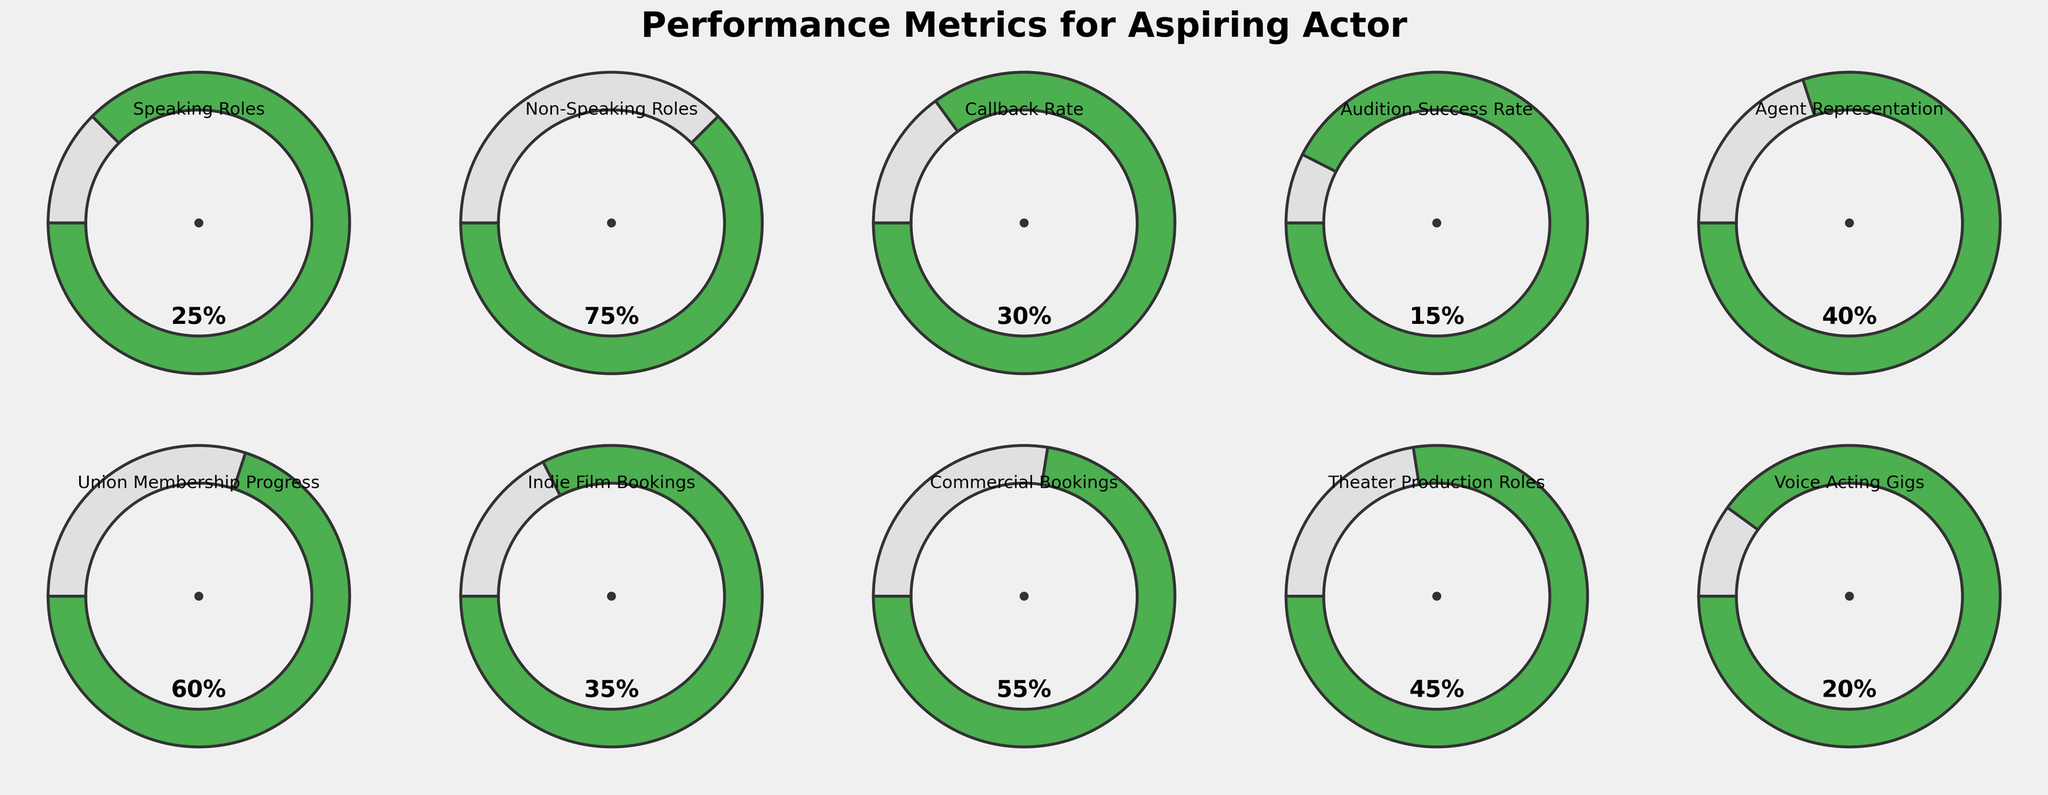What is the title of the figure? The title of the figure is displayed at the top and reads "Performance Metrics for Aspiring Actor." The title helps to understand what information the figure aims to convey.
Answer: Performance Metrics for Aspiring Actor What is the value for 'Voice Acting Gigs'? The value can be found inside the corresponding gauge chart. For 'Voice Acting Gigs,' the value displayed is 20%.
Answer: 20% Which category has the highest percentage value? Examine each gauge chart and compare the values. 'Non-Speaking Roles' has the highest percentage value at 75%.
Answer: Non-Speaking Roles How much higher is the value for 'Commercial Bookings' compared to 'Voice Acting Gigs'? 'Commercial Bookings' is at 55% and 'Voice Acting Gigs' is at 20%. The difference is 55% - 20% = 35%.
Answer: 35% What is the average percentage for 'Agent Representation' and 'Union Membership Progress'? Add the values for the two categories and divide by 2. 'Agent Representation' is 40% and 'Union Membership Progress' is 60%. The average is (40% + 60%) / 2 = 50%.
Answer: 50% Which categories have values greater than 50%? By inspecting the gauge charts, 'Non-Speaking Roles' (75%), 'Commercial Bookings' (55%), and 'Union Membership Progress' (60%) have values greater than 50%.
Answer: Non-Speaking Roles, Commercial Bookings, Union Membership Progress What is the combined percentage of 'Speaking Roles' and 'Callback Rate'? Add the values for 'Speaking Roles' and 'Callback Rate.' 'Speaking Roles' is 25% and 'Callback Rate' is 30%. The combined percentage is 25% + 30% = 55%.
Answer: 55% Is the 'Audition Success Rate' lower than 'Indie Film Bookings'? Compare the values for each category. 'Audition Success Rate' is 15% and 'Indie Film Bookings' is 35%, thus 'Audition Success Rate' is indeed lower.
Answer: Yes Which category represents your progress in securing theater production roles? By looking at the titles of each gauge chart, 'Theater Production Roles' can be identified as the category representing your progress in securing such roles.
Answer: Theater Production Roles 